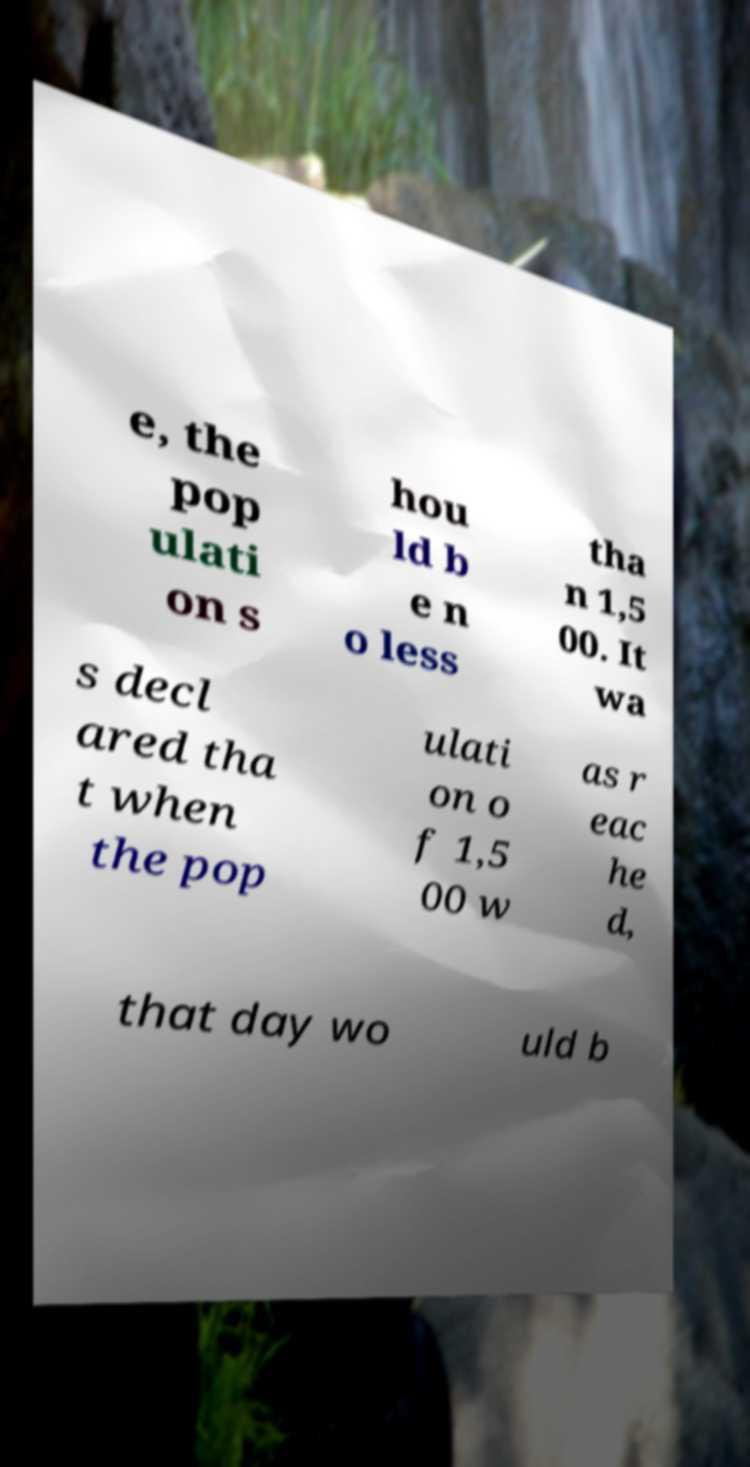I need the written content from this picture converted into text. Can you do that? e, the pop ulati on s hou ld b e n o less tha n 1,5 00. It wa s decl ared tha t when the pop ulati on o f 1,5 00 w as r eac he d, that day wo uld b 